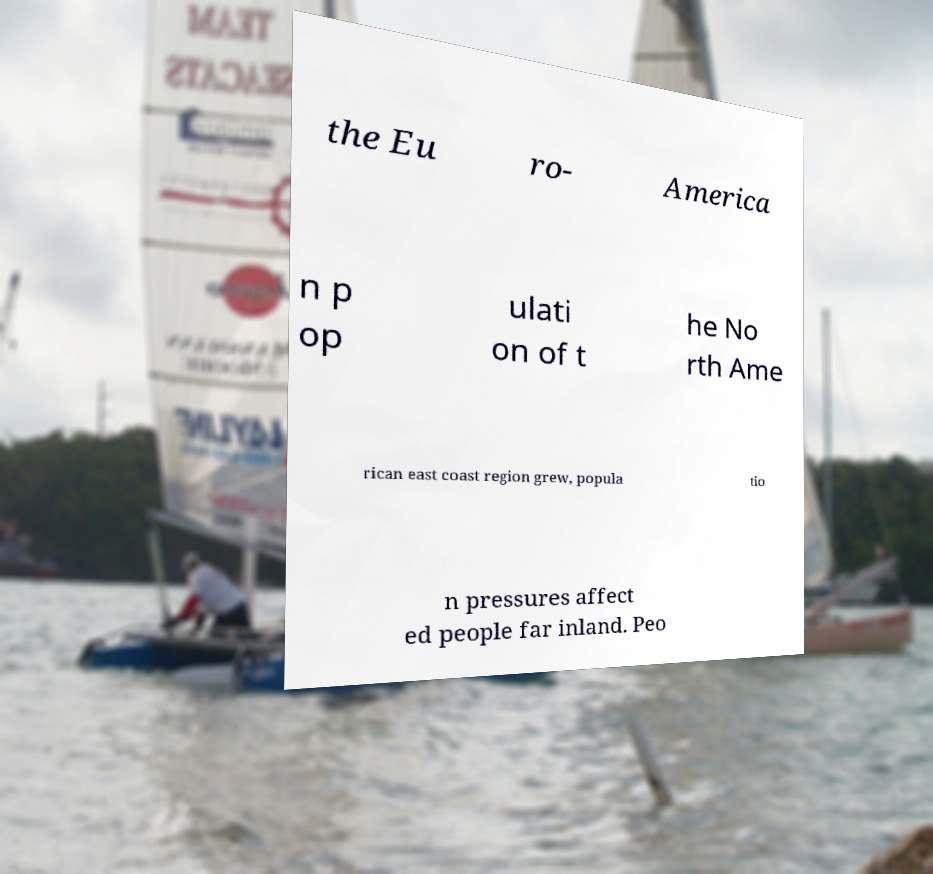Can you read and provide the text displayed in the image?This photo seems to have some interesting text. Can you extract and type it out for me? the Eu ro- America n p op ulati on of t he No rth Ame rican east coast region grew, popula tio n pressures affect ed people far inland. Peo 